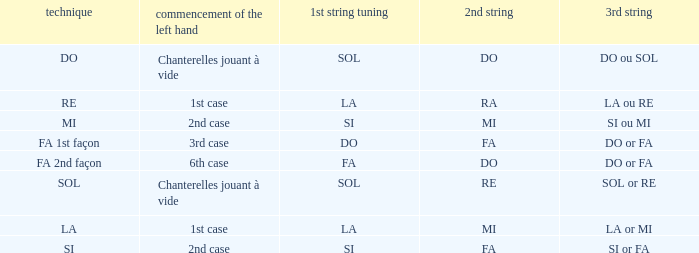For the 2nd string of Ra what is the Depart de la main gauche? 1st case. 